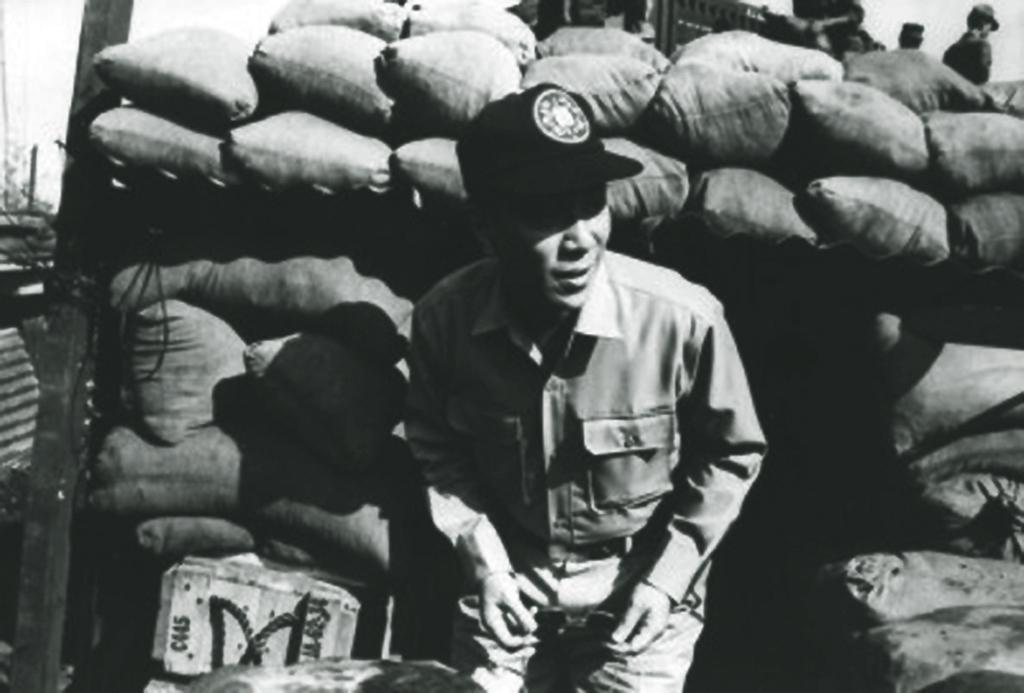Describe this image in one or two sentences. In this image I can see a man is there, he wore shirt, trouser and a cap. Behind him there are gunny bags, this image is in black and white color. 